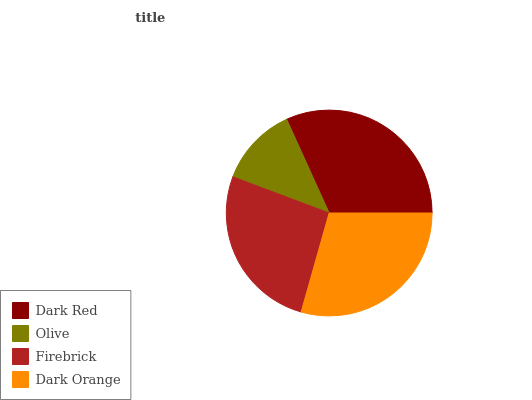Is Olive the minimum?
Answer yes or no. Yes. Is Dark Red the maximum?
Answer yes or no. Yes. Is Firebrick the minimum?
Answer yes or no. No. Is Firebrick the maximum?
Answer yes or no. No. Is Firebrick greater than Olive?
Answer yes or no. Yes. Is Olive less than Firebrick?
Answer yes or no. Yes. Is Olive greater than Firebrick?
Answer yes or no. No. Is Firebrick less than Olive?
Answer yes or no. No. Is Dark Orange the high median?
Answer yes or no. Yes. Is Firebrick the low median?
Answer yes or no. Yes. Is Olive the high median?
Answer yes or no. No. Is Dark Red the low median?
Answer yes or no. No. 